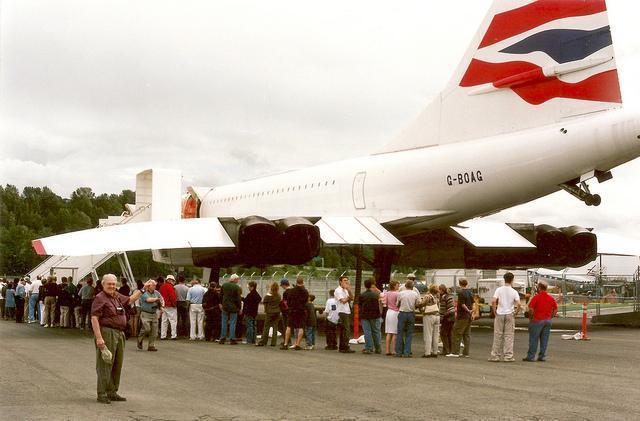How many planes are there?
Give a very brief answer. 1. How many people are in the picture?
Give a very brief answer. 2. How many boats are in the picture?
Give a very brief answer. 0. 